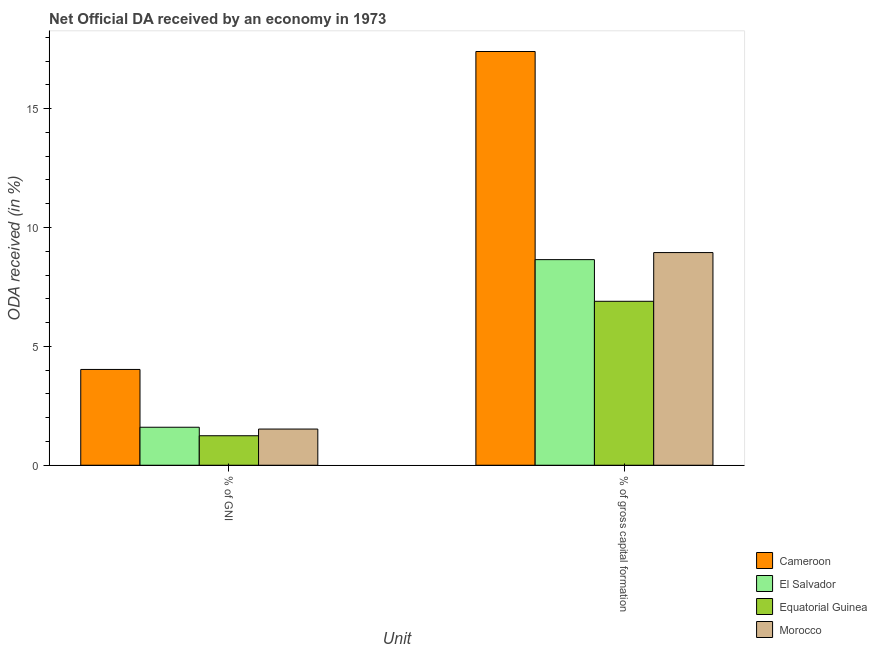Are the number of bars per tick equal to the number of legend labels?
Give a very brief answer. Yes. How many bars are there on the 1st tick from the left?
Keep it short and to the point. 4. What is the label of the 2nd group of bars from the left?
Provide a short and direct response. % of gross capital formation. What is the oda received as percentage of gross capital formation in Equatorial Guinea?
Your answer should be compact. 6.9. Across all countries, what is the maximum oda received as percentage of gni?
Ensure brevity in your answer.  4.03. Across all countries, what is the minimum oda received as percentage of gross capital formation?
Offer a terse response. 6.9. In which country was the oda received as percentage of gni maximum?
Your answer should be compact. Cameroon. In which country was the oda received as percentage of gni minimum?
Your answer should be compact. Equatorial Guinea. What is the total oda received as percentage of gross capital formation in the graph?
Make the answer very short. 41.89. What is the difference between the oda received as percentage of gross capital formation in Cameroon and that in Morocco?
Your answer should be compact. 8.46. What is the difference between the oda received as percentage of gni in Equatorial Guinea and the oda received as percentage of gross capital formation in Morocco?
Give a very brief answer. -7.7. What is the average oda received as percentage of gni per country?
Offer a very short reply. 2.1. What is the difference between the oda received as percentage of gross capital formation and oda received as percentage of gni in El Salvador?
Your answer should be compact. 7.05. What is the ratio of the oda received as percentage of gni in El Salvador to that in Equatorial Guinea?
Ensure brevity in your answer.  1.29. What does the 2nd bar from the left in % of gross capital formation represents?
Provide a succinct answer. El Salvador. What does the 4th bar from the right in % of GNI represents?
Your answer should be compact. Cameroon. How many bars are there?
Keep it short and to the point. 8. How many countries are there in the graph?
Offer a very short reply. 4. What is the difference between two consecutive major ticks on the Y-axis?
Make the answer very short. 5. Does the graph contain any zero values?
Your response must be concise. No. Does the graph contain grids?
Offer a terse response. No. How many legend labels are there?
Keep it short and to the point. 4. How are the legend labels stacked?
Your answer should be very brief. Vertical. What is the title of the graph?
Offer a very short reply. Net Official DA received by an economy in 1973. What is the label or title of the X-axis?
Keep it short and to the point. Unit. What is the label or title of the Y-axis?
Offer a very short reply. ODA received (in %). What is the ODA received (in %) of Cameroon in % of GNI?
Offer a terse response. 4.03. What is the ODA received (in %) of El Salvador in % of GNI?
Offer a terse response. 1.6. What is the ODA received (in %) of Equatorial Guinea in % of GNI?
Your response must be concise. 1.24. What is the ODA received (in %) of Morocco in % of GNI?
Make the answer very short. 1.52. What is the ODA received (in %) in Cameroon in % of gross capital formation?
Your answer should be very brief. 17.4. What is the ODA received (in %) of El Salvador in % of gross capital formation?
Provide a succinct answer. 8.65. What is the ODA received (in %) in Equatorial Guinea in % of gross capital formation?
Keep it short and to the point. 6.9. What is the ODA received (in %) in Morocco in % of gross capital formation?
Your response must be concise. 8.95. Across all Unit, what is the maximum ODA received (in %) of Cameroon?
Make the answer very short. 17.4. Across all Unit, what is the maximum ODA received (in %) in El Salvador?
Give a very brief answer. 8.65. Across all Unit, what is the maximum ODA received (in %) in Equatorial Guinea?
Ensure brevity in your answer.  6.9. Across all Unit, what is the maximum ODA received (in %) of Morocco?
Offer a very short reply. 8.95. Across all Unit, what is the minimum ODA received (in %) in Cameroon?
Your response must be concise. 4.03. Across all Unit, what is the minimum ODA received (in %) of El Salvador?
Ensure brevity in your answer.  1.6. Across all Unit, what is the minimum ODA received (in %) of Equatorial Guinea?
Your response must be concise. 1.24. Across all Unit, what is the minimum ODA received (in %) in Morocco?
Your answer should be very brief. 1.52. What is the total ODA received (in %) in Cameroon in the graph?
Your answer should be compact. 21.43. What is the total ODA received (in %) in El Salvador in the graph?
Offer a very short reply. 10.25. What is the total ODA received (in %) of Equatorial Guinea in the graph?
Give a very brief answer. 8.14. What is the total ODA received (in %) of Morocco in the graph?
Offer a terse response. 10.47. What is the difference between the ODA received (in %) in Cameroon in % of GNI and that in % of gross capital formation?
Make the answer very short. -13.37. What is the difference between the ODA received (in %) in El Salvador in % of GNI and that in % of gross capital formation?
Offer a terse response. -7.05. What is the difference between the ODA received (in %) of Equatorial Guinea in % of GNI and that in % of gross capital formation?
Offer a very short reply. -5.66. What is the difference between the ODA received (in %) in Morocco in % of GNI and that in % of gross capital formation?
Provide a short and direct response. -7.42. What is the difference between the ODA received (in %) of Cameroon in % of GNI and the ODA received (in %) of El Salvador in % of gross capital formation?
Offer a very short reply. -4.62. What is the difference between the ODA received (in %) of Cameroon in % of GNI and the ODA received (in %) of Equatorial Guinea in % of gross capital formation?
Provide a succinct answer. -2.87. What is the difference between the ODA received (in %) of Cameroon in % of GNI and the ODA received (in %) of Morocco in % of gross capital formation?
Your answer should be compact. -4.92. What is the difference between the ODA received (in %) of El Salvador in % of GNI and the ODA received (in %) of Equatorial Guinea in % of gross capital formation?
Provide a succinct answer. -5.3. What is the difference between the ODA received (in %) of El Salvador in % of GNI and the ODA received (in %) of Morocco in % of gross capital formation?
Make the answer very short. -7.35. What is the difference between the ODA received (in %) of Equatorial Guinea in % of GNI and the ODA received (in %) of Morocco in % of gross capital formation?
Your answer should be compact. -7.7. What is the average ODA received (in %) of Cameroon per Unit?
Your answer should be compact. 10.72. What is the average ODA received (in %) of El Salvador per Unit?
Ensure brevity in your answer.  5.12. What is the average ODA received (in %) in Equatorial Guinea per Unit?
Give a very brief answer. 4.07. What is the average ODA received (in %) in Morocco per Unit?
Provide a short and direct response. 5.23. What is the difference between the ODA received (in %) of Cameroon and ODA received (in %) of El Salvador in % of GNI?
Ensure brevity in your answer.  2.43. What is the difference between the ODA received (in %) in Cameroon and ODA received (in %) in Equatorial Guinea in % of GNI?
Provide a succinct answer. 2.79. What is the difference between the ODA received (in %) of Cameroon and ODA received (in %) of Morocco in % of GNI?
Offer a terse response. 2.51. What is the difference between the ODA received (in %) of El Salvador and ODA received (in %) of Equatorial Guinea in % of GNI?
Give a very brief answer. 0.36. What is the difference between the ODA received (in %) of El Salvador and ODA received (in %) of Morocco in % of GNI?
Your answer should be compact. 0.08. What is the difference between the ODA received (in %) of Equatorial Guinea and ODA received (in %) of Morocco in % of GNI?
Ensure brevity in your answer.  -0.28. What is the difference between the ODA received (in %) of Cameroon and ODA received (in %) of El Salvador in % of gross capital formation?
Make the answer very short. 8.75. What is the difference between the ODA received (in %) in Cameroon and ODA received (in %) in Equatorial Guinea in % of gross capital formation?
Offer a very short reply. 10.51. What is the difference between the ODA received (in %) in Cameroon and ODA received (in %) in Morocco in % of gross capital formation?
Your response must be concise. 8.46. What is the difference between the ODA received (in %) of El Salvador and ODA received (in %) of Equatorial Guinea in % of gross capital formation?
Offer a terse response. 1.75. What is the difference between the ODA received (in %) in El Salvador and ODA received (in %) in Morocco in % of gross capital formation?
Ensure brevity in your answer.  -0.3. What is the difference between the ODA received (in %) in Equatorial Guinea and ODA received (in %) in Morocco in % of gross capital formation?
Offer a very short reply. -2.05. What is the ratio of the ODA received (in %) of Cameroon in % of GNI to that in % of gross capital formation?
Provide a succinct answer. 0.23. What is the ratio of the ODA received (in %) in El Salvador in % of GNI to that in % of gross capital formation?
Ensure brevity in your answer.  0.18. What is the ratio of the ODA received (in %) in Equatorial Guinea in % of GNI to that in % of gross capital formation?
Make the answer very short. 0.18. What is the ratio of the ODA received (in %) of Morocco in % of GNI to that in % of gross capital formation?
Give a very brief answer. 0.17. What is the difference between the highest and the second highest ODA received (in %) in Cameroon?
Your answer should be very brief. 13.37. What is the difference between the highest and the second highest ODA received (in %) of El Salvador?
Provide a short and direct response. 7.05. What is the difference between the highest and the second highest ODA received (in %) of Equatorial Guinea?
Provide a short and direct response. 5.66. What is the difference between the highest and the second highest ODA received (in %) of Morocco?
Keep it short and to the point. 7.42. What is the difference between the highest and the lowest ODA received (in %) of Cameroon?
Ensure brevity in your answer.  13.37. What is the difference between the highest and the lowest ODA received (in %) of El Salvador?
Ensure brevity in your answer.  7.05. What is the difference between the highest and the lowest ODA received (in %) in Equatorial Guinea?
Your response must be concise. 5.66. What is the difference between the highest and the lowest ODA received (in %) in Morocco?
Offer a terse response. 7.42. 